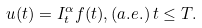<formula> <loc_0><loc_0><loc_500><loc_500>u ( t ) = I _ { t } ^ { \alpha } f ( t ) , ( a . e . ) \, t \leq T .</formula> 